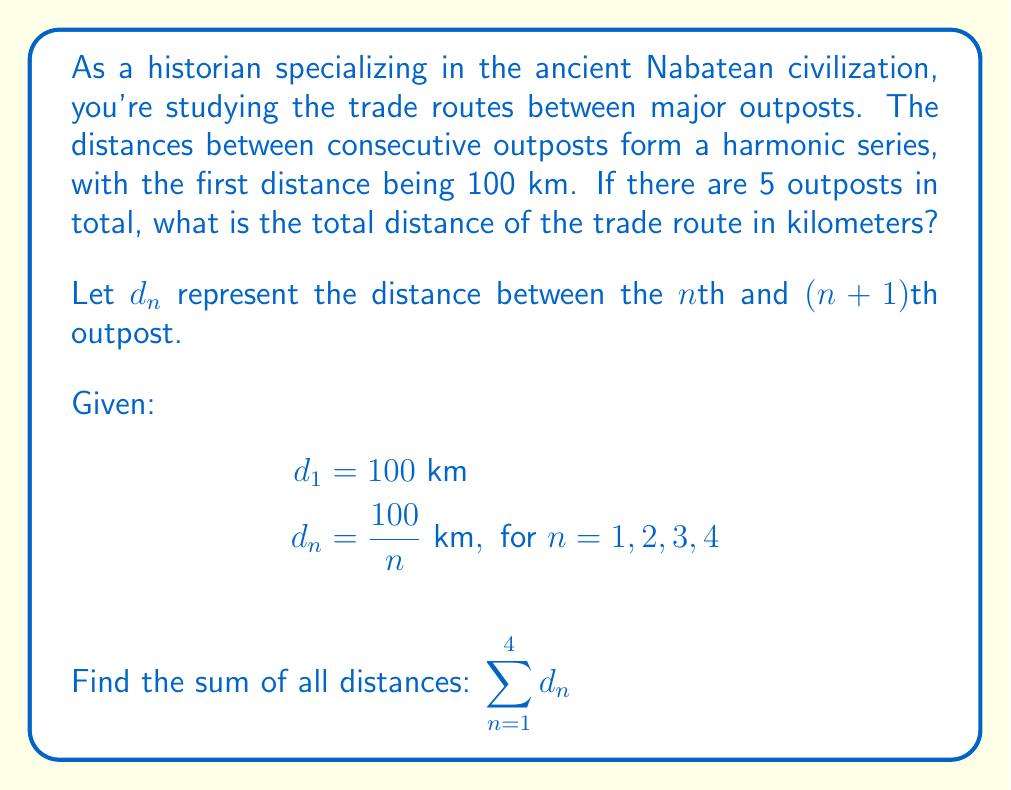Show me your answer to this math problem. To solve this problem, we need to calculate the sum of the harmonic series for the first 4 terms, then multiply the result by 100 km.

The harmonic series is given by:

$$\sum_{n=1}^4 \frac{1}{n}$$

Let's calculate each term:

1. $\frac{1}{1} = 1$
2. $\frac{1}{2} = 0.5$
3. $\frac{1}{3} \approx 0.3333$
4. $\frac{1}{4} = 0.25$

Now, let's sum these terms:

$$1 + 0.5 + 0.3333 + 0.25 = 2.0833$$

Since each term in our original series is 100 times the corresponding term in the harmonic series, we multiply our result by 100:

$$100 \times 2.0833 = 208.33 \text{ km}$$

Therefore, the total distance of the trade route is approximately 208.33 km.
Answer: The total distance of the trade route is approximately 208.33 km. 